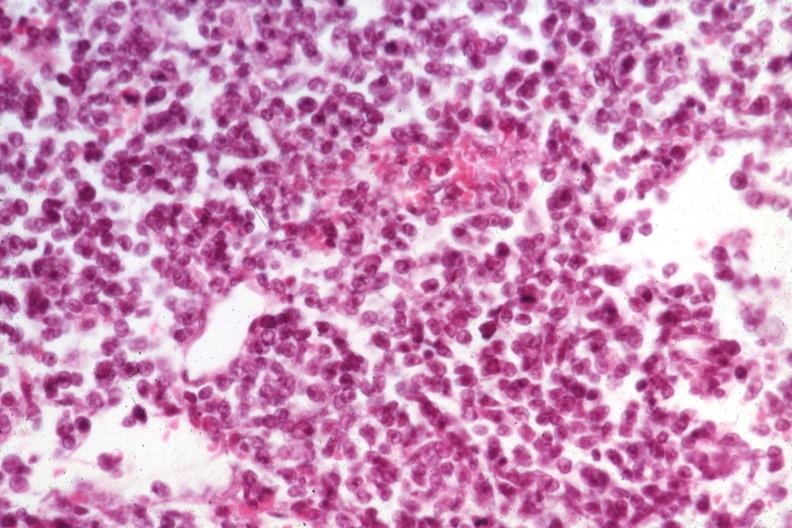what does this image show?
Answer the question using a single word or phrase. Fair cell detail at best medium size cells 